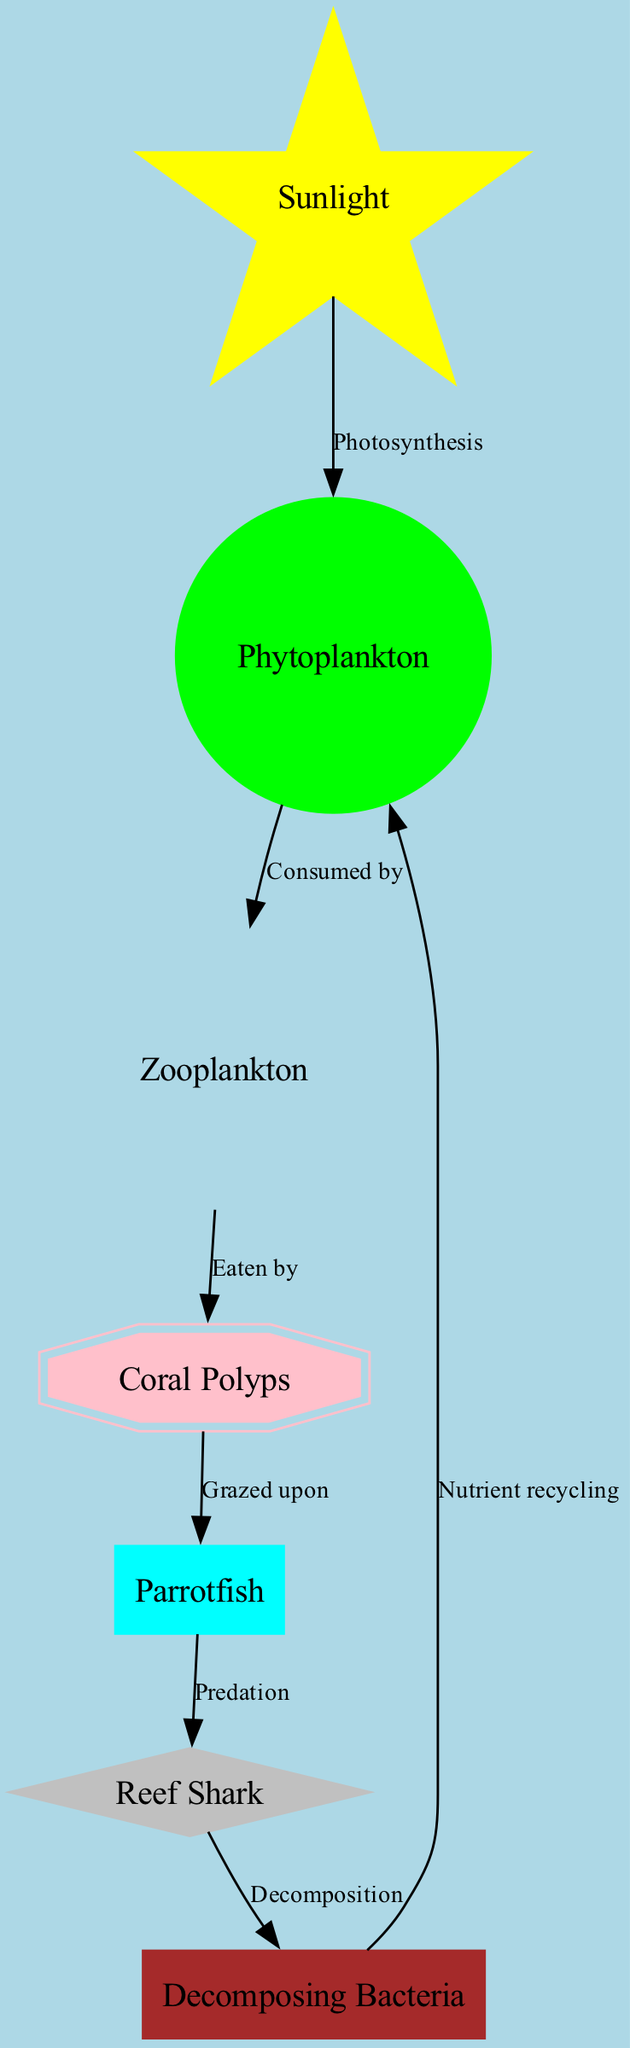What is the primary source of energy in this marine food chain? The diagram indicates that sunlight is the starting node of the food chain, which is directly linked to phytoplankton through the process of photosynthesis. Therefore, sunlight is the primary source of energy.
Answer: Sunlight How many nodes are present in the diagram? By counting each of the nodes listed, there are a total of 7 nodes related to the food chain, including those for sunlight, phytoplankton, zooplankton, coral polyps, parrotfish, reef shark, and bacteria.
Answer: 7 What do zooplankton consume? The diagram illustrates that zooplankton are consumed by coral polyps as shown by the directed edge labeled "Eaten by." Thus, zooplankton are the food source for coral polyps.
Answer: Coral Polyps Which two organisms are directly linked through predation? The diagram shows a direct edge from parrotfish to reef shark labeled "Predation," indicating that reef sharks prey on parrotfish. This is the relationship in question.
Answer: Parrotfish What role do decomposing bacteria play in this ecosystem? According to the diagram, decomposing bacteria are linked to reef sharks through the process labeled "Decomposition." They also recycle nutrients back to phytoplankton, indicating their role in nutrient recycling and decomposition.
Answer: Nutrient recycling How do phytoplankton interact with sunlight? The diagram displays an edge from sunlight to phytoplankton labeled "Photosynthesis," demonstrating that phytoplankton convert sunlight into energy through this process.
Answer: Photosynthesis Who grazes upon coral polyps? The diagram specifies that parrotfish are the organisms that graze upon coral polyps, indicated by the edge labeled "Grazed upon."
Answer: Parrotfish What is the final destination of energy flow in this ecosystem? By following the directed connections in the diagram, the final destination of energy flow leads to bacteria after passing through reef sharks. The nutrient recycling indicates a circular return back to phytoplankton, indicating an energy loop.
Answer: Bacteria 